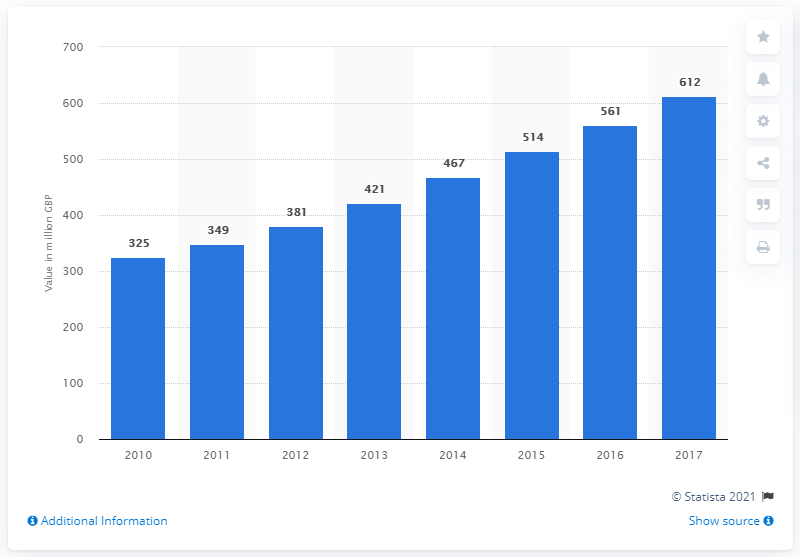Specify some key components in this picture. In 2017, the estimated size of the security management segment was approximately 612. 